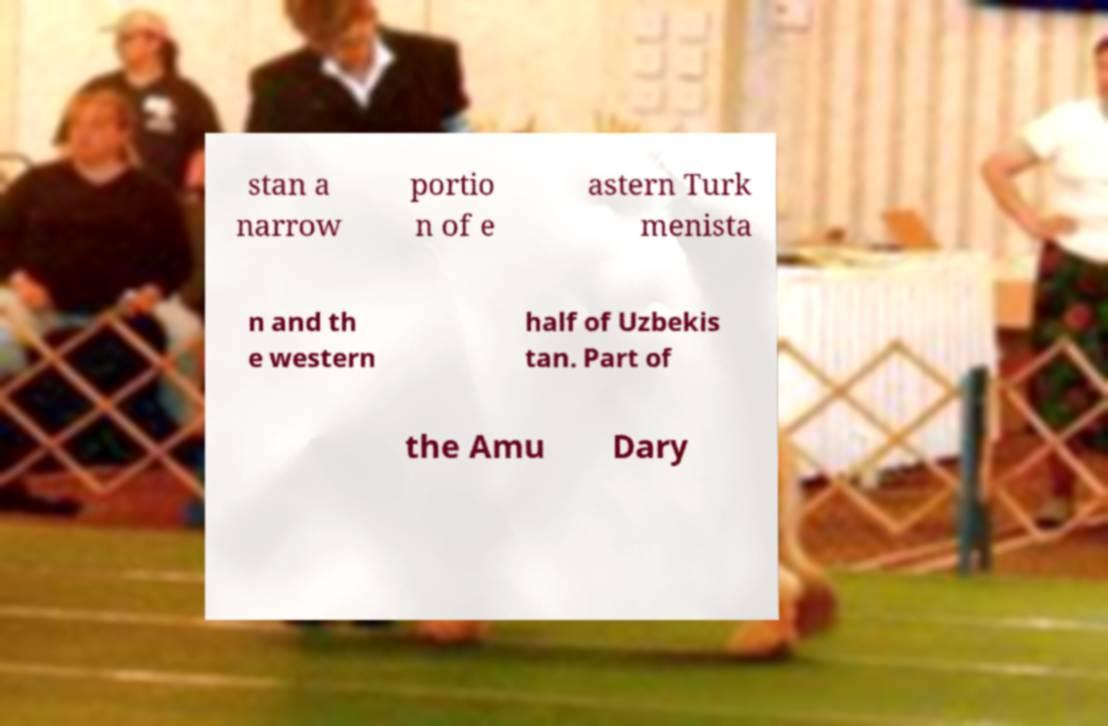Could you extract and type out the text from this image? stan a narrow portio n of e astern Turk menista n and th e western half of Uzbekis tan. Part of the Amu Dary 